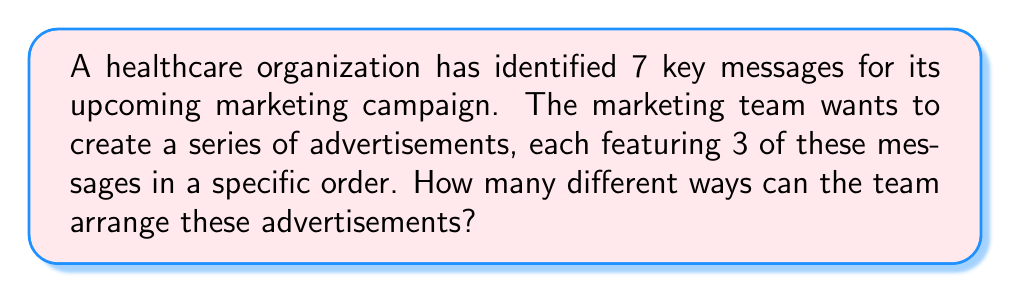Provide a solution to this math problem. To solve this problem, we need to use the concept of permutations. We are selecting 3 messages out of 7 and arranging them in a specific order. This is a permutation without repetition.

The formula for permutations without repetition is:

$$P(n,r) = \frac{n!}{(n-r)!}$$

Where:
$n$ = total number of items to choose from
$r$ = number of items being chosen and arranged

In this case:
$n = 7$ (total number of key messages)
$r = 3$ (number of messages used in each advertisement)

Plugging these values into the formula:

$$P(7,3) = \frac{7!}{(7-3)!} = \frac{7!}{4!}$$

Let's calculate this step-by-step:

1) $7! = 7 \times 6 \times 5 \times 4!$
2) $\frac{7!}{4!} = \frac{7 \times 6 \times 5 \times 4!}{4!}$
3) The $4!$ cancels out in the numerator and denominator
4) $7 \times 6 \times 5 = 210$

Therefore, there are 210 different ways to arrange 3 messages out of 7 for the advertisements.
Answer: 210 ways 